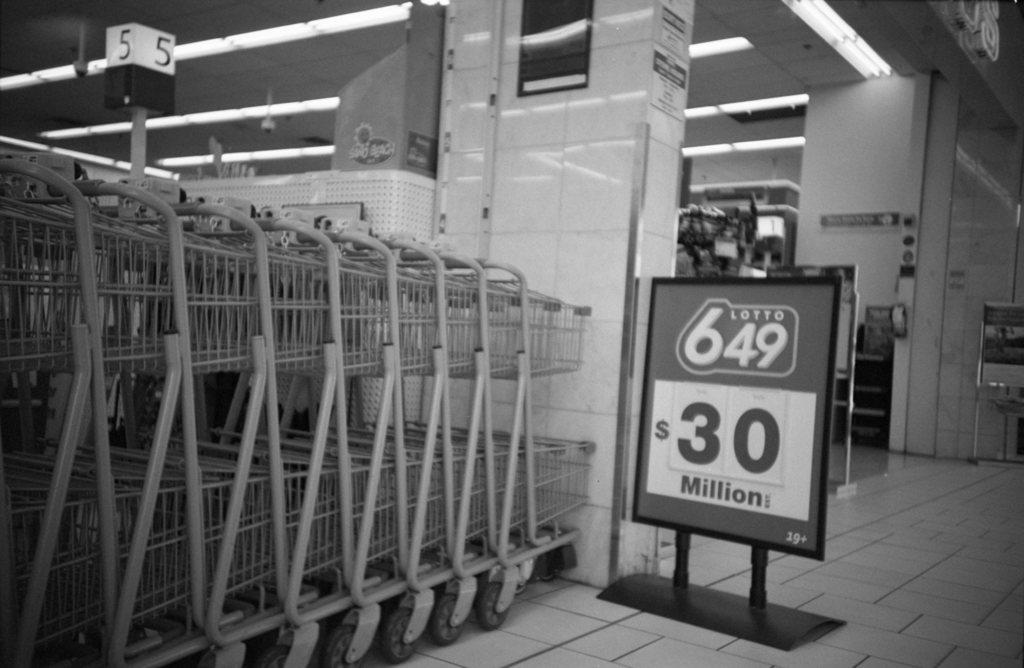How much did the lottery reach in the picture?
Make the answer very short. $30 million. What register are these shopping carts near?
Give a very brief answer. 5. 